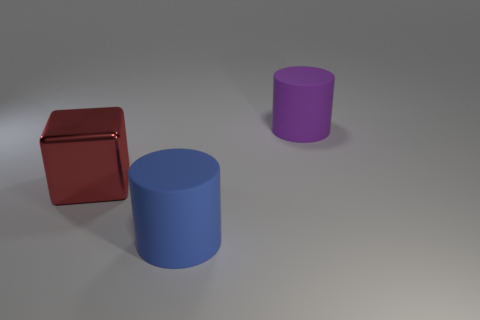What is the shape of the purple object that is made of the same material as the large blue object? The shape of the purple object, which appears to be made of the same matte, solid material as the large blue object, is a cylinder. 